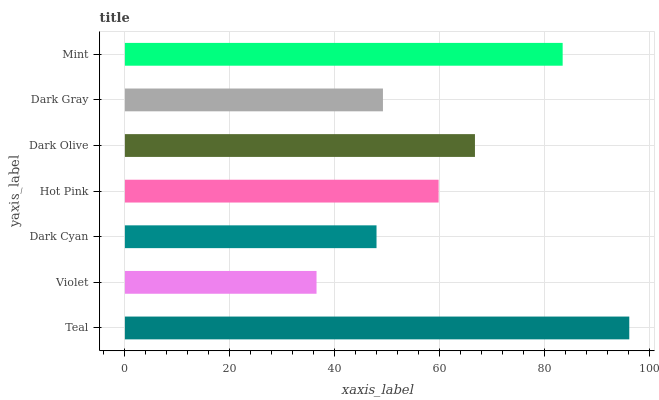Is Violet the minimum?
Answer yes or no. Yes. Is Teal the maximum?
Answer yes or no. Yes. Is Dark Cyan the minimum?
Answer yes or no. No. Is Dark Cyan the maximum?
Answer yes or no. No. Is Dark Cyan greater than Violet?
Answer yes or no. Yes. Is Violet less than Dark Cyan?
Answer yes or no. Yes. Is Violet greater than Dark Cyan?
Answer yes or no. No. Is Dark Cyan less than Violet?
Answer yes or no. No. Is Hot Pink the high median?
Answer yes or no. Yes. Is Hot Pink the low median?
Answer yes or no. Yes. Is Mint the high median?
Answer yes or no. No. Is Dark Olive the low median?
Answer yes or no. No. 